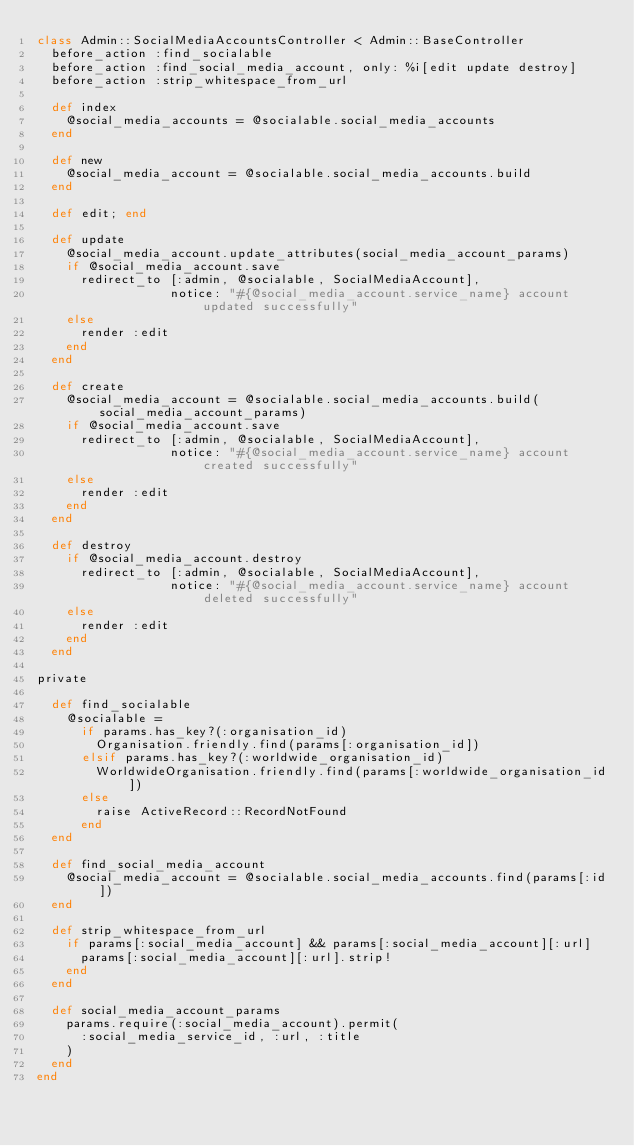<code> <loc_0><loc_0><loc_500><loc_500><_Ruby_>class Admin::SocialMediaAccountsController < Admin::BaseController
  before_action :find_socialable
  before_action :find_social_media_account, only: %i[edit update destroy]
  before_action :strip_whitespace_from_url

  def index
    @social_media_accounts = @socialable.social_media_accounts
  end

  def new
    @social_media_account = @socialable.social_media_accounts.build
  end

  def edit; end

  def update
    @social_media_account.update_attributes(social_media_account_params)
    if @social_media_account.save
      redirect_to [:admin, @socialable, SocialMediaAccount],
                  notice: "#{@social_media_account.service_name} account updated successfully"
    else
      render :edit
    end
  end

  def create
    @social_media_account = @socialable.social_media_accounts.build(social_media_account_params)
    if @social_media_account.save
      redirect_to [:admin, @socialable, SocialMediaAccount],
                  notice: "#{@social_media_account.service_name} account created successfully"
    else
      render :edit
    end
  end

  def destroy
    if @social_media_account.destroy
      redirect_to [:admin, @socialable, SocialMediaAccount],
                  notice: "#{@social_media_account.service_name} account deleted successfully"
    else
      render :edit
    end
  end

private

  def find_socialable
    @socialable =
      if params.has_key?(:organisation_id)
        Organisation.friendly.find(params[:organisation_id])
      elsif params.has_key?(:worldwide_organisation_id)
        WorldwideOrganisation.friendly.find(params[:worldwide_organisation_id])
      else
        raise ActiveRecord::RecordNotFound
      end
  end

  def find_social_media_account
    @social_media_account = @socialable.social_media_accounts.find(params[:id])
  end

  def strip_whitespace_from_url
    if params[:social_media_account] && params[:social_media_account][:url]
      params[:social_media_account][:url].strip!
    end
  end

  def social_media_account_params
    params.require(:social_media_account).permit(
      :social_media_service_id, :url, :title
    )
  end
end
</code> 